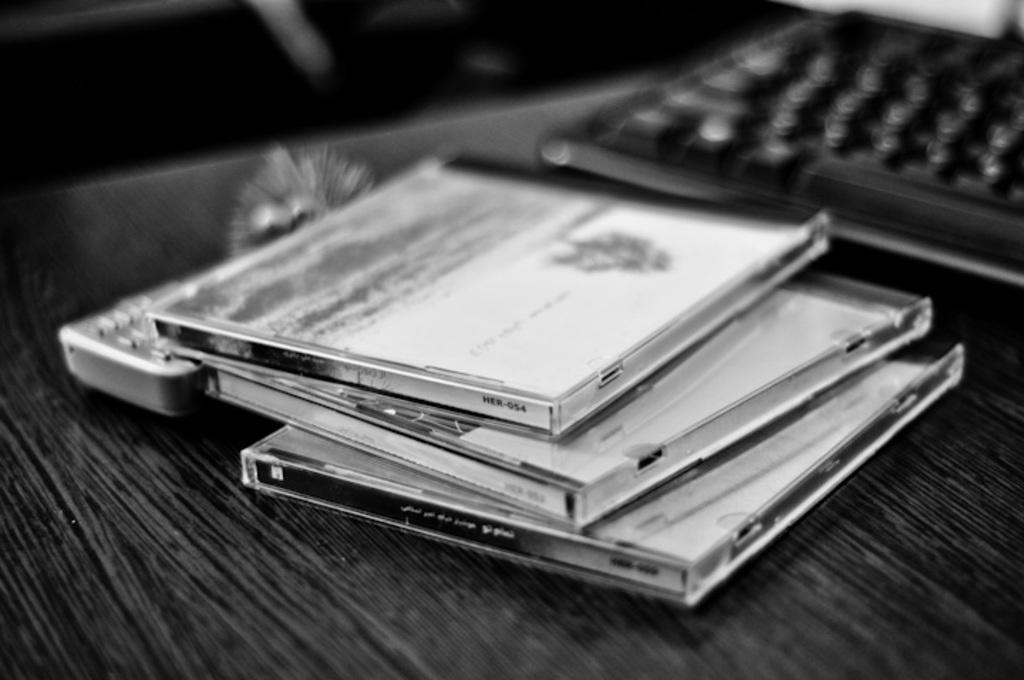What electronic device is visible in the image? There is a keyboard in the image. What other object can be seen in the image? There is a remote in the image. What is the surface on which the keyboard and remote are placed? The keyboard and remote are on a table in the image. How many cakes are being served on the basketball court by the ladybug in the image? There are no cakes, basketball court, or ladybug present in the image. 